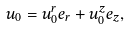<formula> <loc_0><loc_0><loc_500><loc_500>u _ { 0 } = u _ { 0 } ^ { r } e _ { r } + u _ { 0 } ^ { z } e _ { z } ,</formula> 